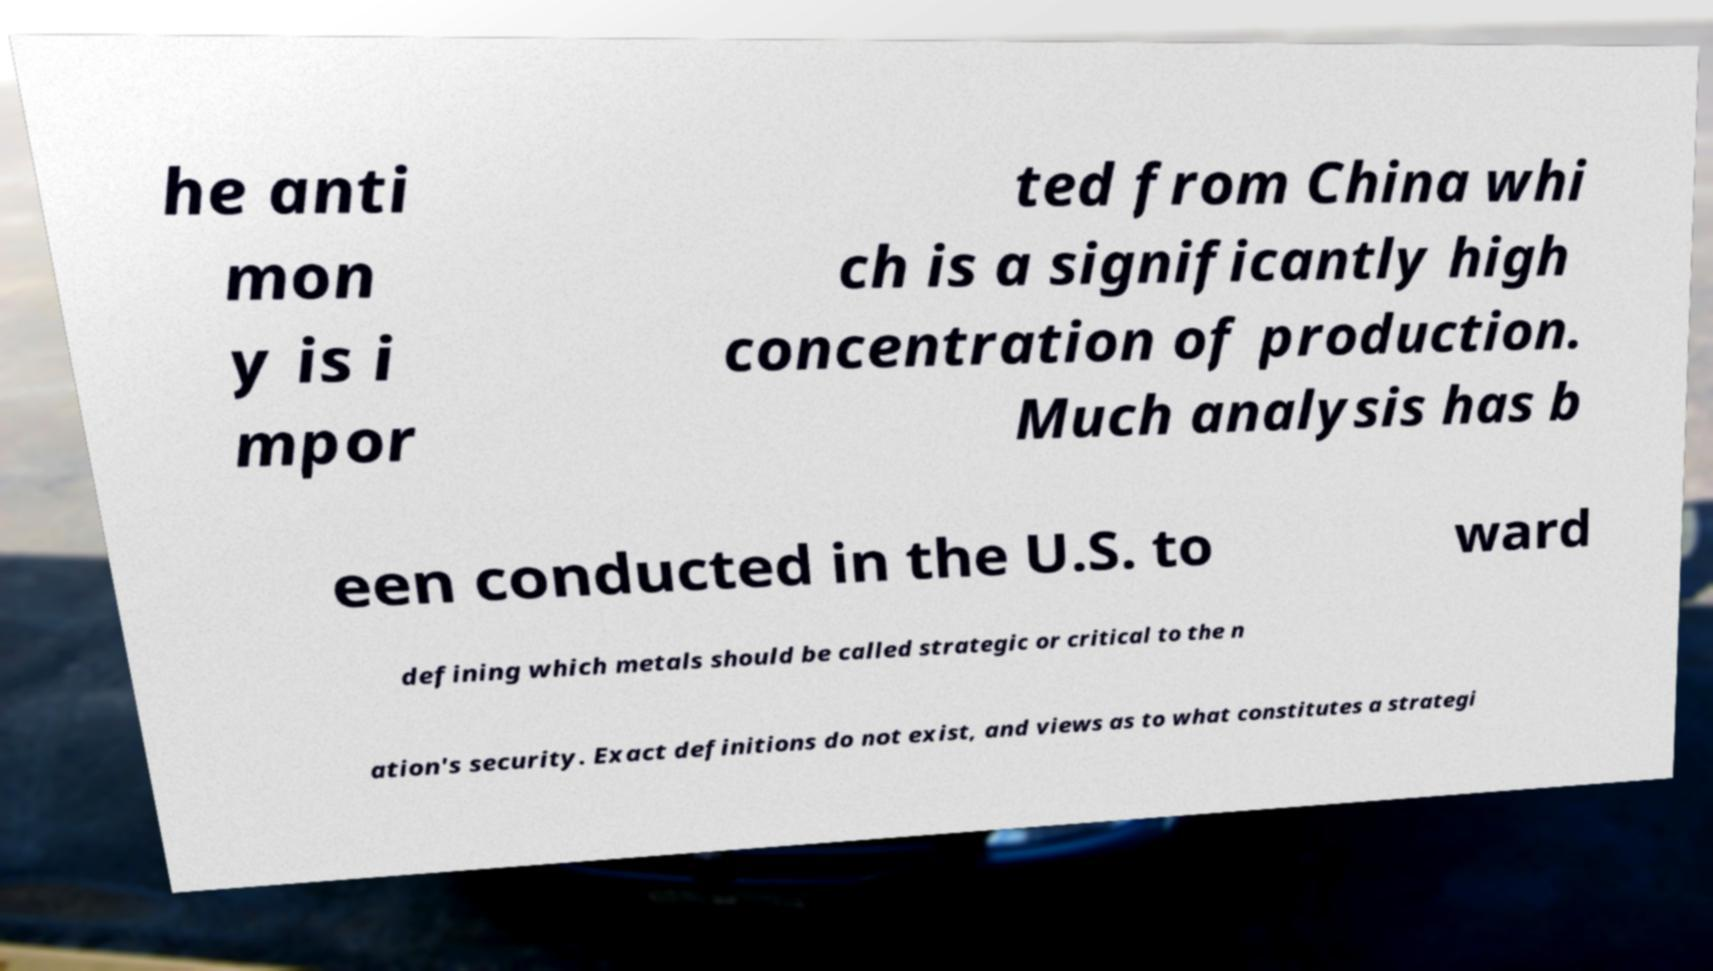For documentation purposes, I need the text within this image transcribed. Could you provide that? he anti mon y is i mpor ted from China whi ch is a significantly high concentration of production. Much analysis has b een conducted in the U.S. to ward defining which metals should be called strategic or critical to the n ation's security. Exact definitions do not exist, and views as to what constitutes a strategi 